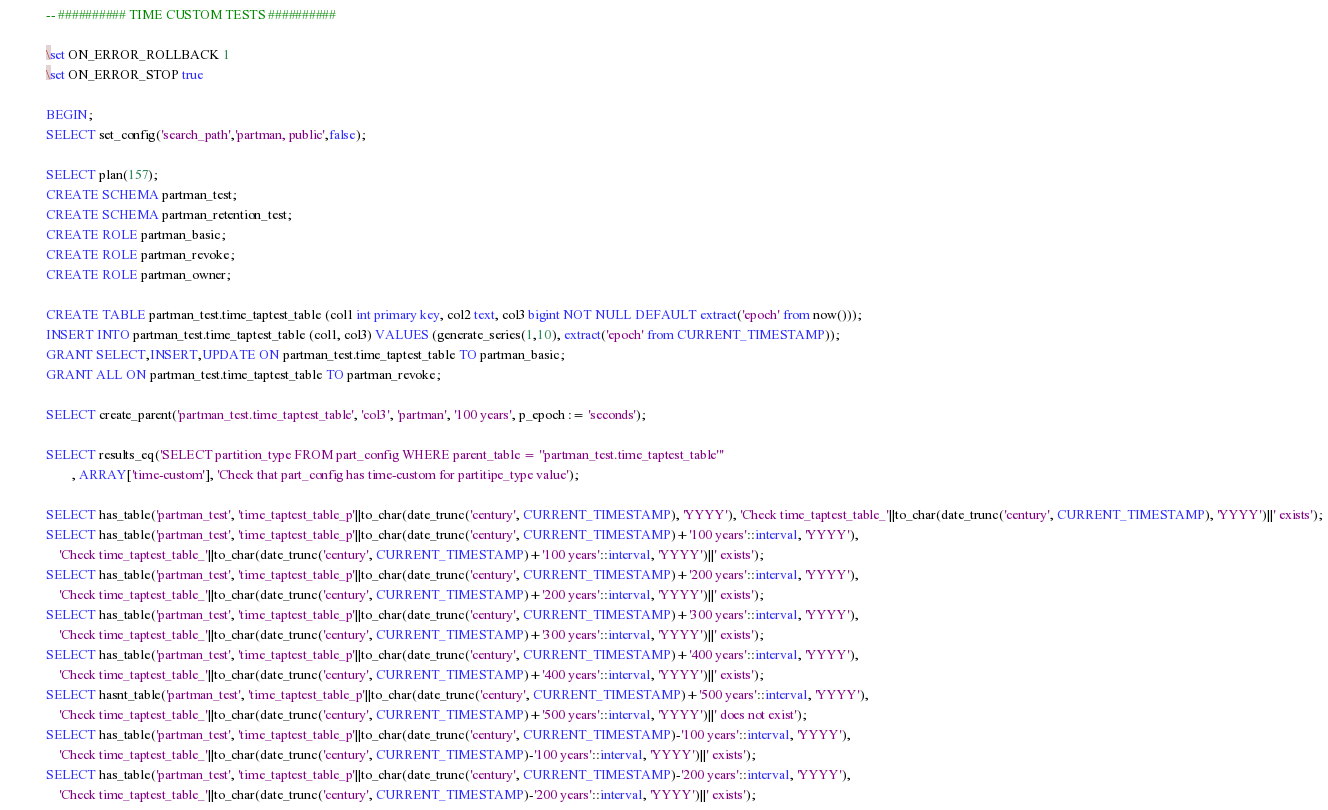Convert code to text. <code><loc_0><loc_0><loc_500><loc_500><_SQL_>-- ########## TIME CUSTOM TESTS ##########

\set ON_ERROR_ROLLBACK 1
\set ON_ERROR_STOP true

BEGIN;
SELECT set_config('search_path','partman, public',false);

SELECT plan(157);
CREATE SCHEMA partman_test;
CREATE SCHEMA partman_retention_test;
CREATE ROLE partman_basic;
CREATE ROLE partman_revoke;
CREATE ROLE partman_owner;

CREATE TABLE partman_test.time_taptest_table (col1 int primary key, col2 text, col3 bigint NOT NULL DEFAULT extract('epoch' from now()));
INSERT INTO partman_test.time_taptest_table (col1, col3) VALUES (generate_series(1,10), extract('epoch' from CURRENT_TIMESTAMP));
GRANT SELECT,INSERT,UPDATE ON partman_test.time_taptest_table TO partman_basic;
GRANT ALL ON partman_test.time_taptest_table TO partman_revoke;

SELECT create_parent('partman_test.time_taptest_table', 'col3', 'partman', '100 years', p_epoch := 'seconds');

SELECT results_eq('SELECT partition_type FROM part_config WHERE parent_table = ''partman_test.time_taptest_table'''
        , ARRAY['time-custom'], 'Check that part_config has time-custom for partitipe_type value');

SELECT has_table('partman_test', 'time_taptest_table_p'||to_char(date_trunc('century', CURRENT_TIMESTAMP), 'YYYY'), 'Check time_taptest_table_'||to_char(date_trunc('century', CURRENT_TIMESTAMP), 'YYYY')||' exists');
SELECT has_table('partman_test', 'time_taptest_table_p'||to_char(date_trunc('century', CURRENT_TIMESTAMP)+'100 years'::interval, 'YYYY'), 
    'Check time_taptest_table_'||to_char(date_trunc('century', CURRENT_TIMESTAMP)+'100 years'::interval, 'YYYY')||' exists');
SELECT has_table('partman_test', 'time_taptest_table_p'||to_char(date_trunc('century', CURRENT_TIMESTAMP)+'200 years'::interval, 'YYYY'), 
    'Check time_taptest_table_'||to_char(date_trunc('century', CURRENT_TIMESTAMP)+'200 years'::interval, 'YYYY')||' exists');
SELECT has_table('partman_test', 'time_taptest_table_p'||to_char(date_trunc('century', CURRENT_TIMESTAMP)+'300 years'::interval, 'YYYY'), 
    'Check time_taptest_table_'||to_char(date_trunc('century', CURRENT_TIMESTAMP)+'300 years'::interval, 'YYYY')||' exists');
SELECT has_table('partman_test', 'time_taptest_table_p'||to_char(date_trunc('century', CURRENT_TIMESTAMP)+'400 years'::interval, 'YYYY'), 
    'Check time_taptest_table_'||to_char(date_trunc('century', CURRENT_TIMESTAMP)+'400 years'::interval, 'YYYY')||' exists');
SELECT hasnt_table('partman_test', 'time_taptest_table_p'||to_char(date_trunc('century', CURRENT_TIMESTAMP)+'500 years'::interval, 'YYYY'), 
    'Check time_taptest_table_'||to_char(date_trunc('century', CURRENT_TIMESTAMP)+'500 years'::interval, 'YYYY')||' does not exist');
SELECT has_table('partman_test', 'time_taptest_table_p'||to_char(date_trunc('century', CURRENT_TIMESTAMP)-'100 years'::interval, 'YYYY'), 
    'Check time_taptest_table_'||to_char(date_trunc('century', CURRENT_TIMESTAMP)-'100 years'::interval, 'YYYY')||' exists');
SELECT has_table('partman_test', 'time_taptest_table_p'||to_char(date_trunc('century', CURRENT_TIMESTAMP)-'200 years'::interval, 'YYYY'), 
    'Check time_taptest_table_'||to_char(date_trunc('century', CURRENT_TIMESTAMP)-'200 years'::interval, 'YYYY')||' exists');</code> 